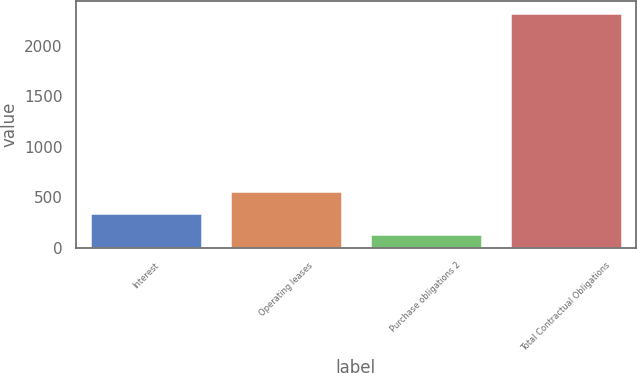Convert chart to OTSL. <chart><loc_0><loc_0><loc_500><loc_500><bar_chart><fcel>Interest<fcel>Operating leases<fcel>Purchase obligations 2<fcel>Total Contractual Obligations<nl><fcel>345.32<fcel>560.34<fcel>130.3<fcel>2326.22<nl></chart> 